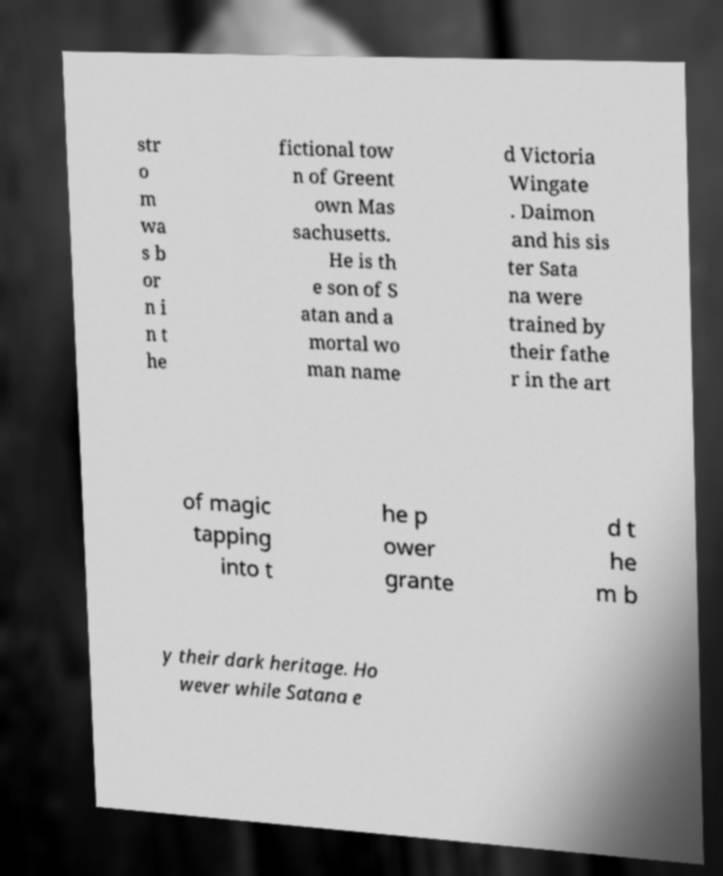Please identify and transcribe the text found in this image. str o m wa s b or n i n t he fictional tow n of Greent own Mas sachusetts. He is th e son of S atan and a mortal wo man name d Victoria Wingate . Daimon and his sis ter Sata na were trained by their fathe r in the art of magic tapping into t he p ower grante d t he m b y their dark heritage. Ho wever while Satana e 